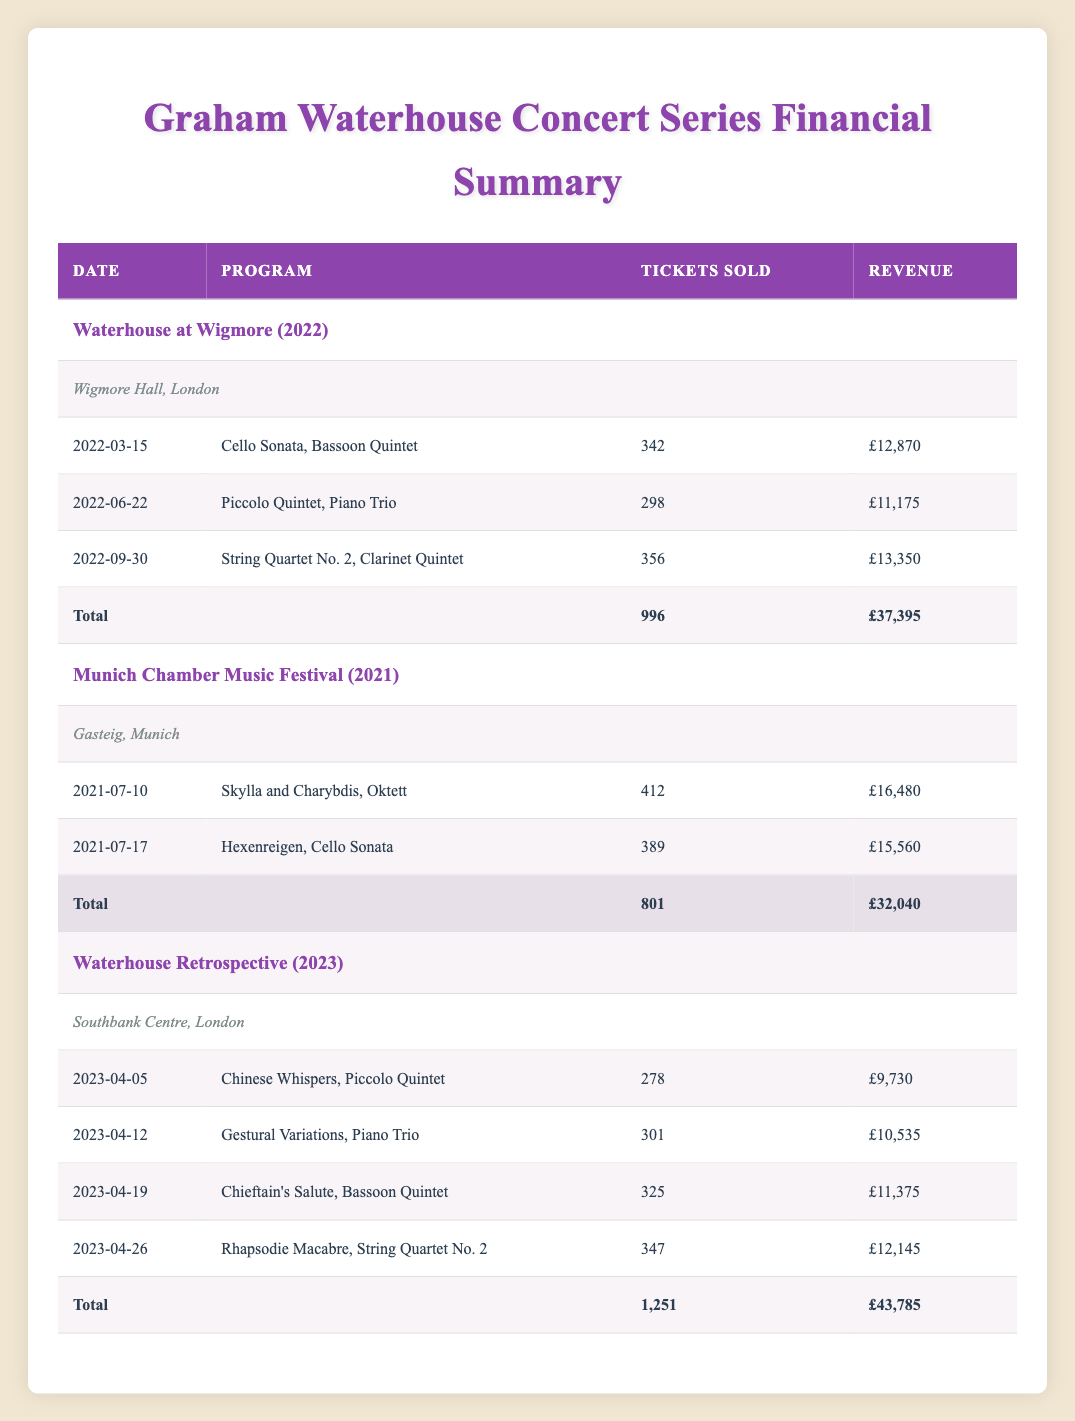What is the total revenue from the "Waterhouse at Wigmore" concert series? The "Waterhouse at Wigmore" concert series has three performances, with revenues of 12870, 11175, and 13350 respectively. Adding these values gives a total revenue of 12870 + 11175 + 13350 = 37395.
Answer: 37395 How many tickets were sold overall in the "Waterhouse Retrospective" concert series? The "Waterhouse Retrospective" concert series has four performances with tickets sold of 278, 301, 325, and 347. The total tickets sold can be calculated by adding these values: 278 + 301 + 325 + 347 = 1251.
Answer: 1251 Did the "Munich Chamber Music Festival" have more tickets sold than the "Waterhouse at Wigmore"? The "Munich Chamber Music Festival" sold 412 + 389 = 801 tickets in total, while the "Waterhouse at Wigmore" sold 996 tickets. Thus, 801 is less than 996, making the statement false.
Answer: No Which concert series had the highest single performance revenue? Looking at the individual performances, the highest revenue from any single performance is 16480 from the "Skylla and Charybdis, Oktett" at the "Munich Chamber Music Festival."
Answer: 16480 What is the average revenue per performance for the "Waterhouse Retrospective"? The "Waterhouse Retrospective" has a total revenue of 43785 from 4 performances. The average revenue per performance can be calculated by dividing the total revenue by the number of performances: 43785 / 4 = 10946.25.
Answer: 10946.25 Is the total number of tickets sold in the "Munich Chamber Music Festival" greater than that of the "Waterhouse Retrospective"? The total tickets sold for the "Munich Chamber Music Festival" is 801, while for the "Waterhouse Retrospective," it is 1251. Since 801 is less than 1251, the statement is false.
Answer: No How many performances were held in the "Waterhouse at Wigmore"? The "Waterhouse at Wigmore" series comprises three performances as listed under that series in the table.
Answer: 3 What was the total revenue generated from all performances across the three concert series? The total revenue can be calculated by summing the total revenues from each series: 37395 (Waterhouse at Wigmore) + 32040 (Munich Chamber Music Festival) + 43785 (Waterhouse Retrospective) = 113220.
Answer: 113220 Which concert series had the least number of tickets sold? By comparing the ticket sales, "Waterhouse at Wigmore" has 996, "Munich Chamber Music Festival" has 801, and "Waterhouse Retrospective" has 1251. The "Munich Chamber Music Festival" has the least with 801 tickets sold.
Answer: Munich Chamber Music Festival 